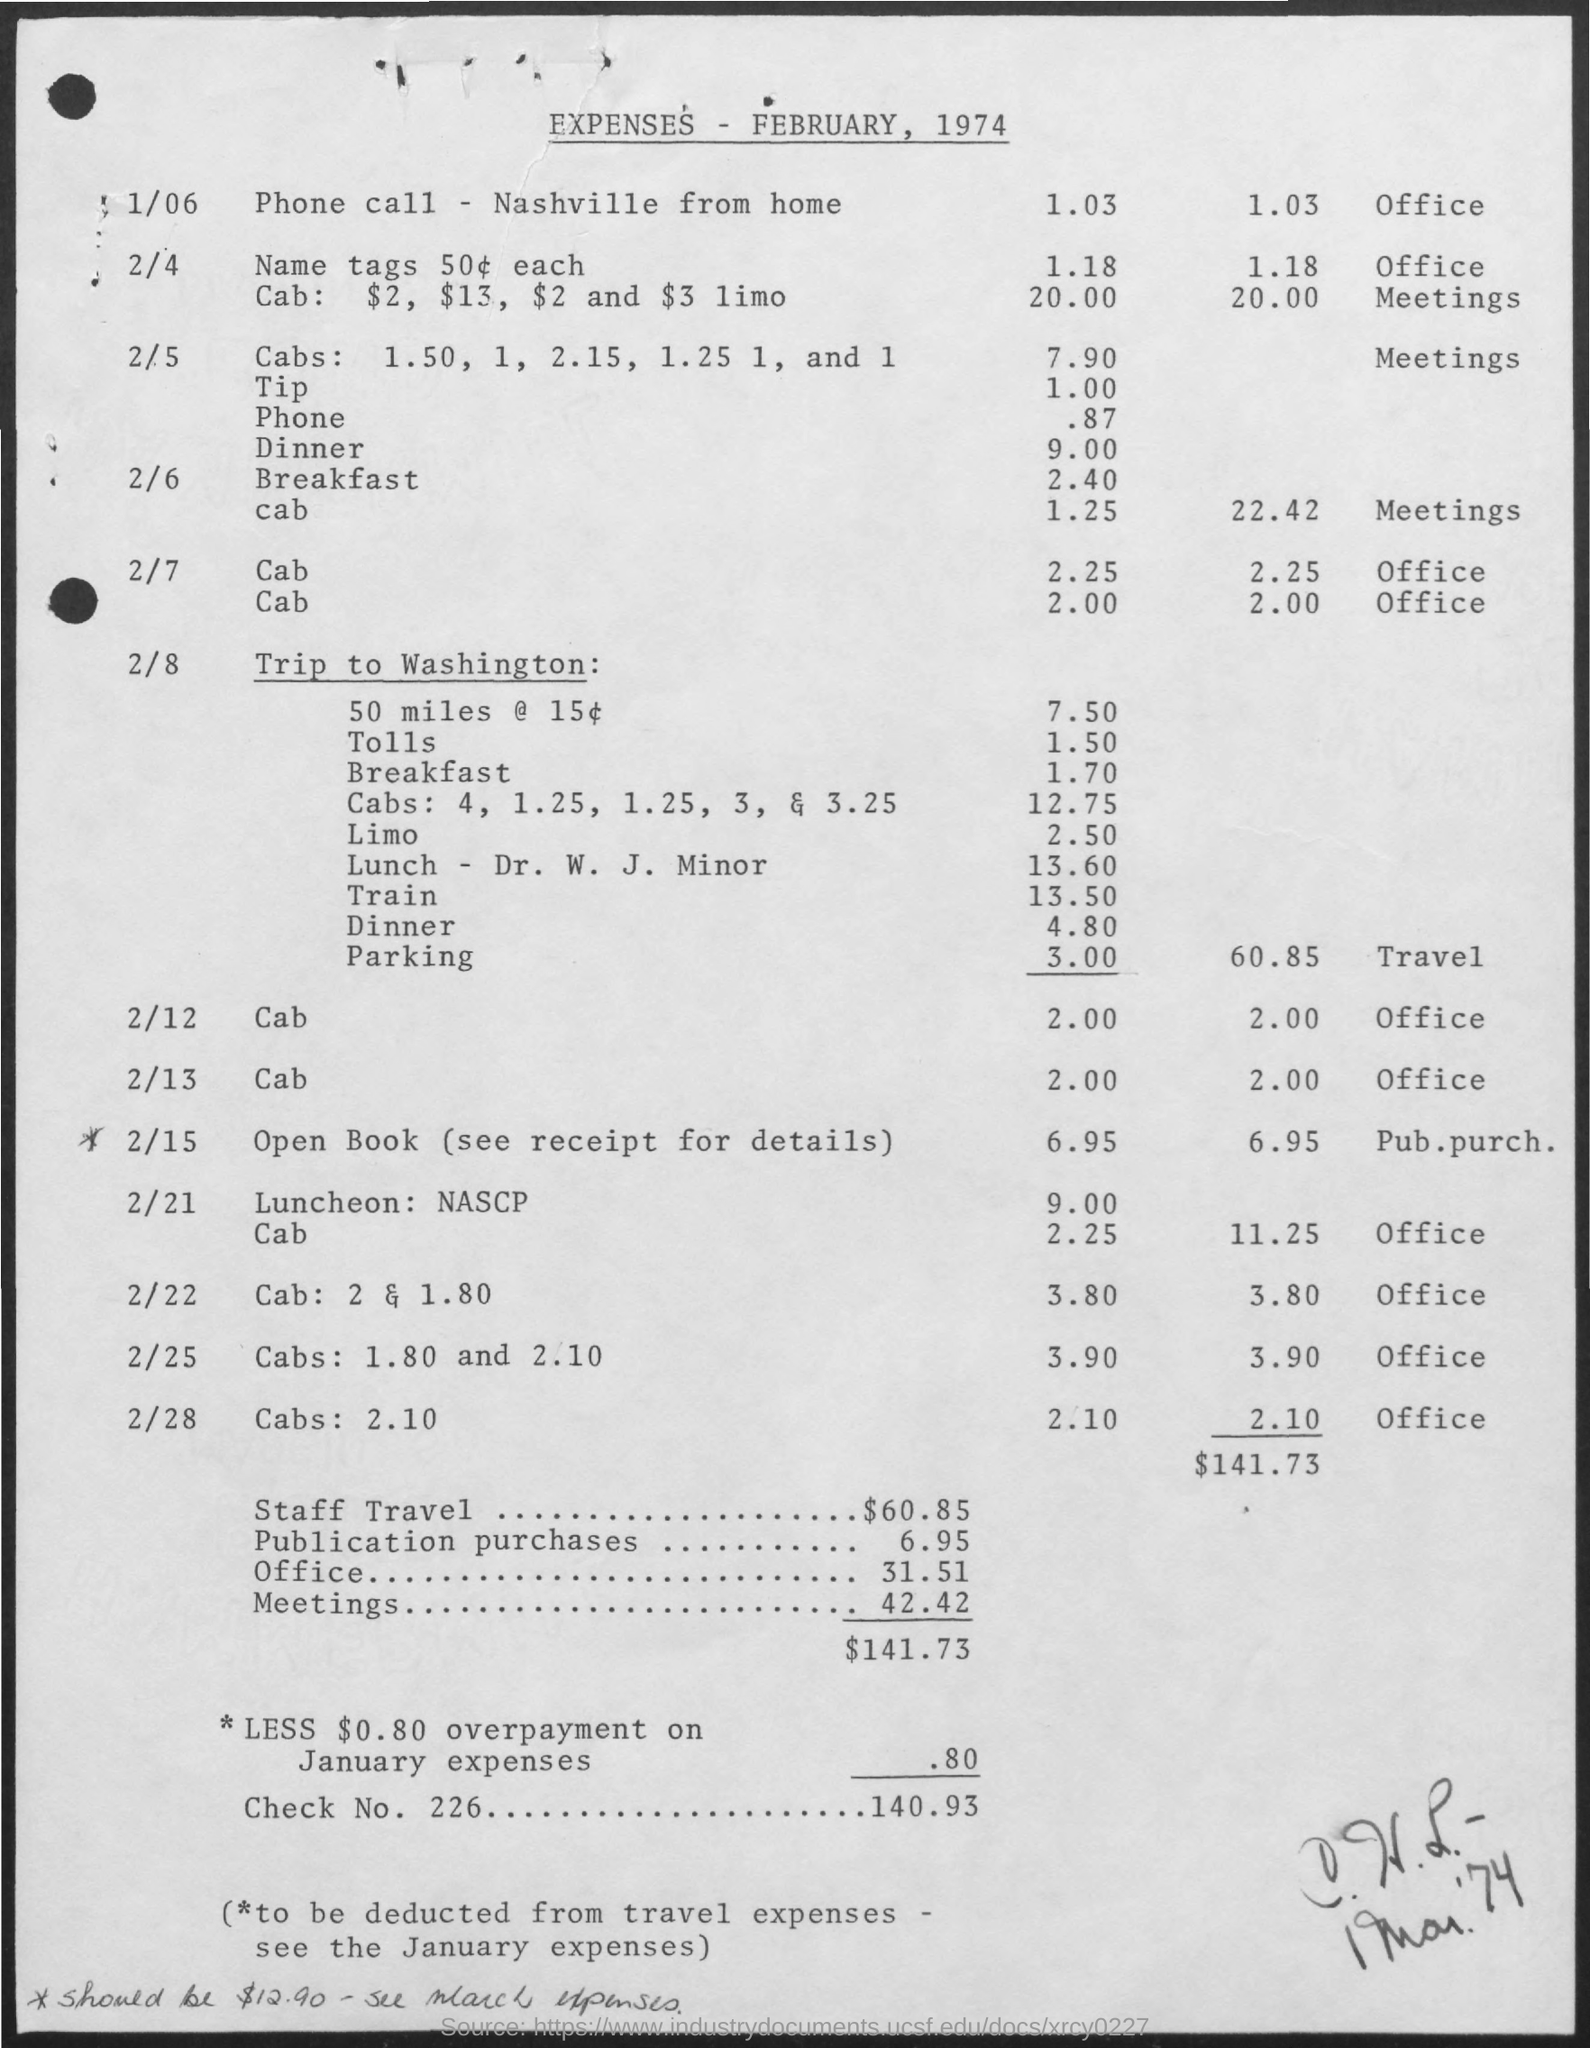Identify some key points in this picture. The amount of Check No. 226 is 140.93... The document in question is titled "Expenses - February, 1974. 